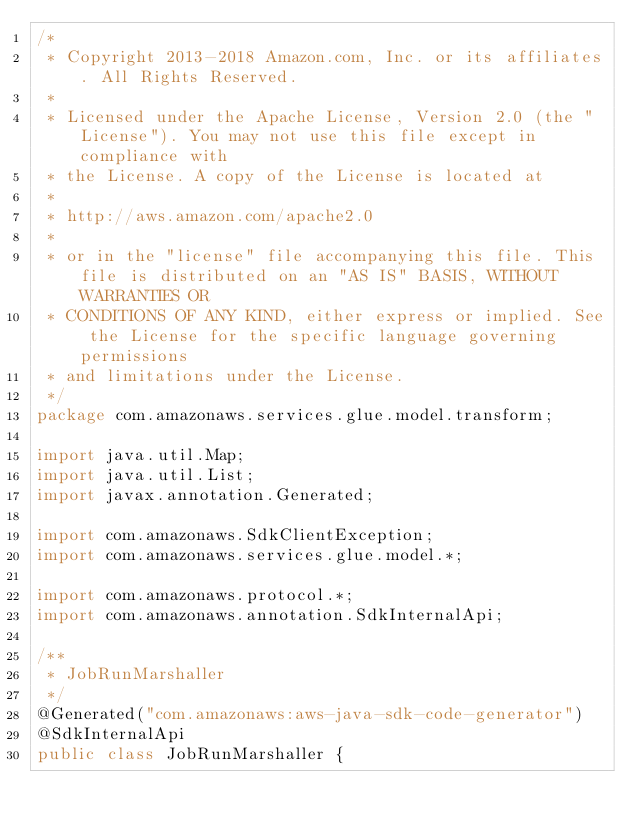Convert code to text. <code><loc_0><loc_0><loc_500><loc_500><_Java_>/*
 * Copyright 2013-2018 Amazon.com, Inc. or its affiliates. All Rights Reserved.
 * 
 * Licensed under the Apache License, Version 2.0 (the "License"). You may not use this file except in compliance with
 * the License. A copy of the License is located at
 * 
 * http://aws.amazon.com/apache2.0
 * 
 * or in the "license" file accompanying this file. This file is distributed on an "AS IS" BASIS, WITHOUT WARRANTIES OR
 * CONDITIONS OF ANY KIND, either express or implied. See the License for the specific language governing permissions
 * and limitations under the License.
 */
package com.amazonaws.services.glue.model.transform;

import java.util.Map;
import java.util.List;
import javax.annotation.Generated;

import com.amazonaws.SdkClientException;
import com.amazonaws.services.glue.model.*;

import com.amazonaws.protocol.*;
import com.amazonaws.annotation.SdkInternalApi;

/**
 * JobRunMarshaller
 */
@Generated("com.amazonaws:aws-java-sdk-code-generator")
@SdkInternalApi
public class JobRunMarshaller {
</code> 